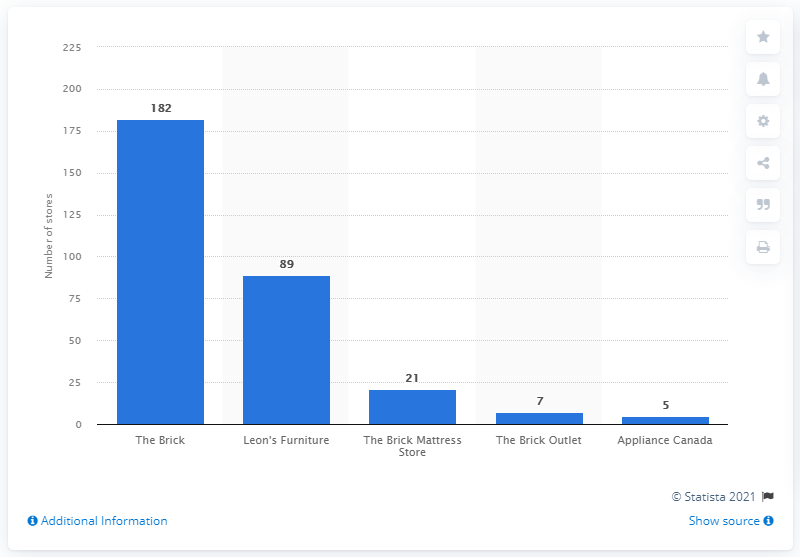Mention a couple of crucial points in this snapshot. Leon's Furniture Limited's brand is called The Brick Outlet. 